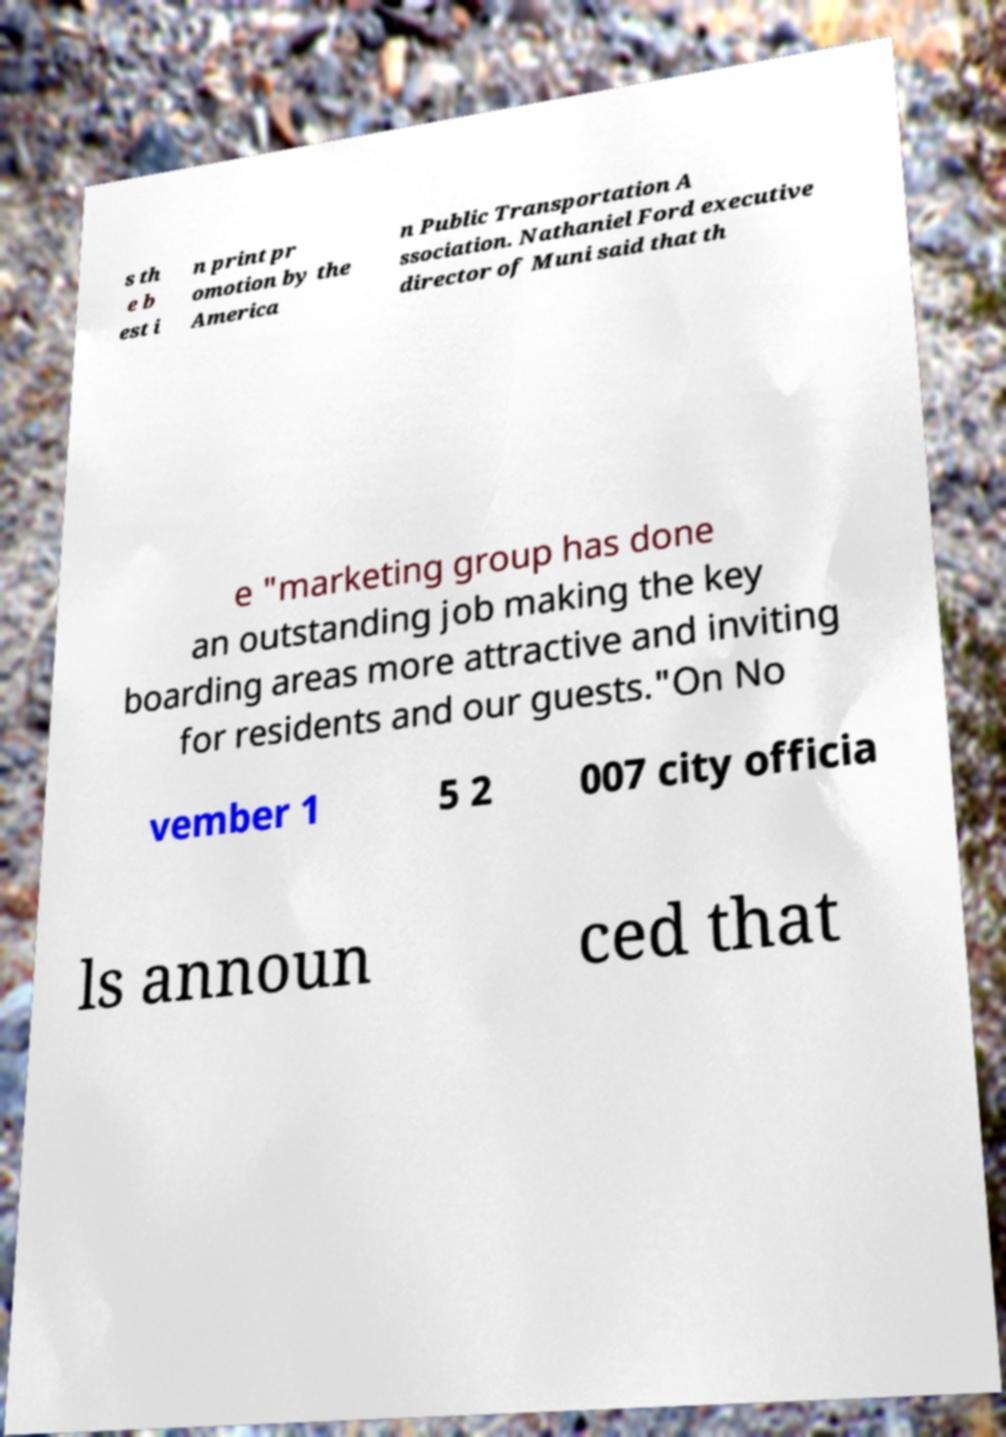Could you extract and type out the text from this image? s th e b est i n print pr omotion by the America n Public Transportation A ssociation. Nathaniel Ford executive director of Muni said that th e "marketing group has done an outstanding job making the key boarding areas more attractive and inviting for residents and our guests."On No vember 1 5 2 007 city officia ls announ ced that 